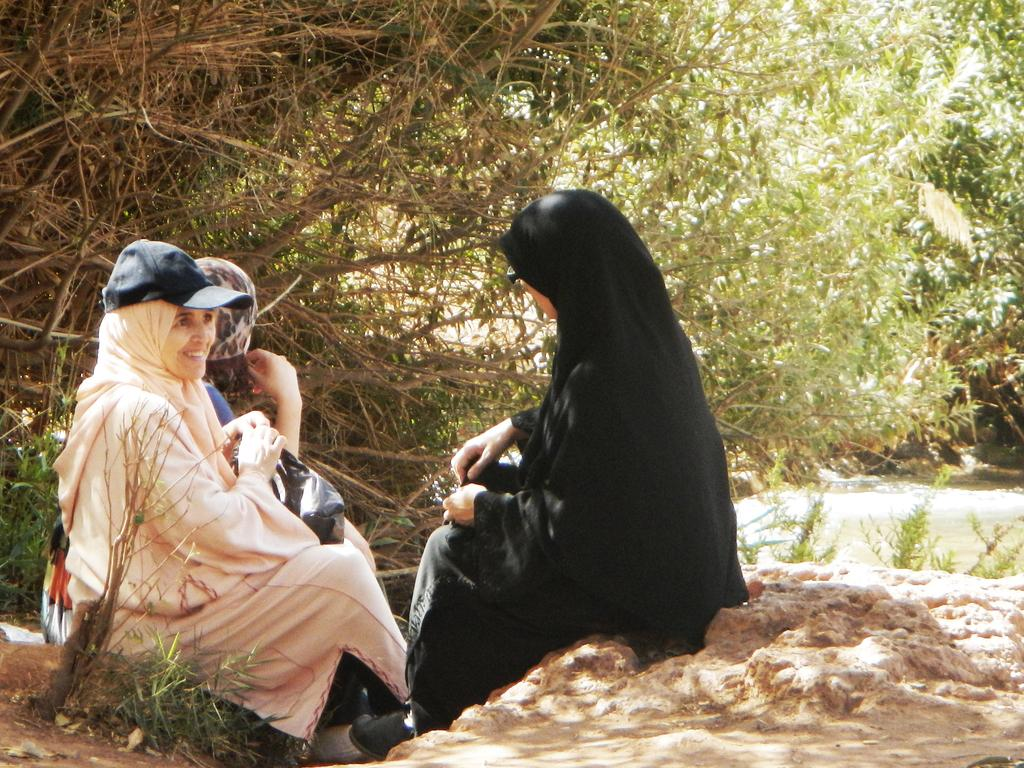How many women are in the image? There are three women in the image. What are the women doing in the image? The women are sitting. What type of clothing are the women wearing? The women are wearing abayas. What can be seen in the background of the image? There are trees in the background of the image. What news is the beginner uncle sharing with the women in the image? There is no news or uncle present in the image; it only features three women sitting and wearing abayas with trees in the background. 